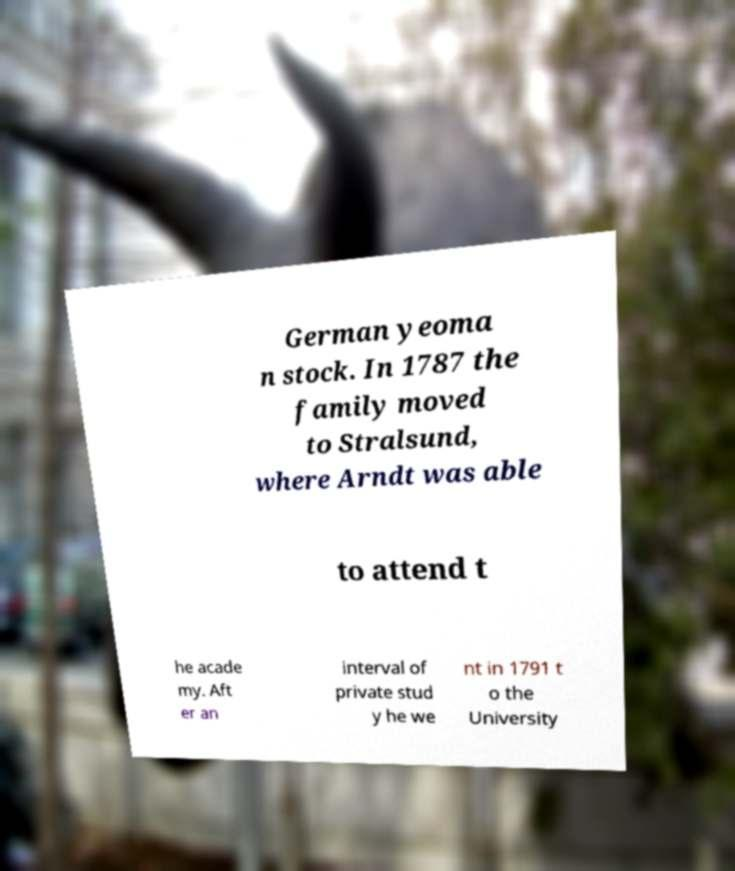Can you read and provide the text displayed in the image?This photo seems to have some interesting text. Can you extract and type it out for me? German yeoma n stock. In 1787 the family moved to Stralsund, where Arndt was able to attend t he acade my. Aft er an interval of private stud y he we nt in 1791 t o the University 